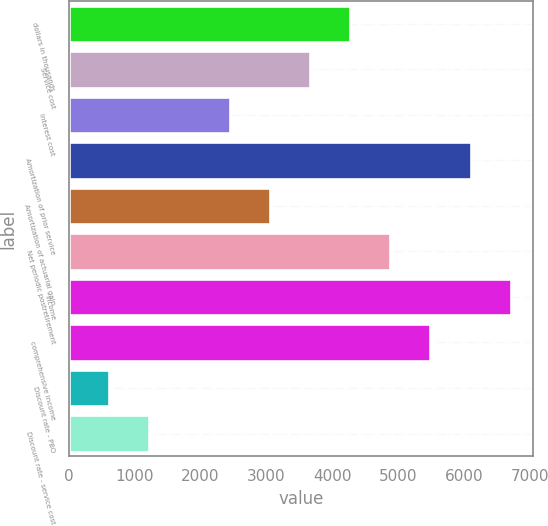Convert chart to OTSL. <chart><loc_0><loc_0><loc_500><loc_500><bar_chart><fcel>dollars in thousands<fcel>Service cost<fcel>Interest cost<fcel>Amortization of prior service<fcel>Amortization of actuarial gain<fcel>Net periodic postretirement<fcel>income<fcel>comprehensive income<fcel>Discount rate - PBO<fcel>Discount rate - service cost<nl><fcel>4267.37<fcel>3658.16<fcel>2439.74<fcel>6095<fcel>3048.95<fcel>4876.58<fcel>6704.21<fcel>5485.79<fcel>612.11<fcel>1221.32<nl></chart> 